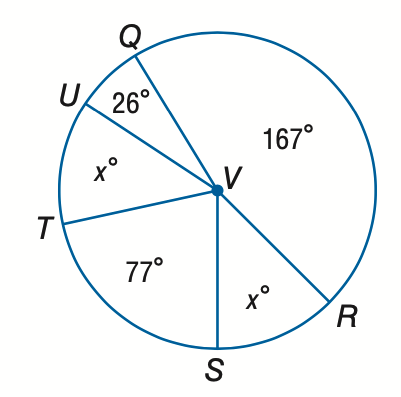Question: Find the value of x.
Choices:
A. 22.5
B. 45
C. 60
D. 90
Answer with the letter. Answer: B 